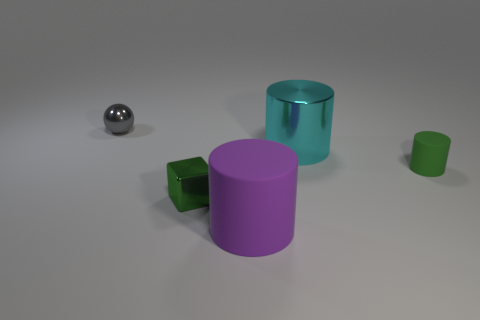Subtract all rubber cylinders. How many cylinders are left? 1 Add 1 cyan cylinders. How many objects exist? 6 Subtract all cubes. How many objects are left? 4 Subtract 0 blue cylinders. How many objects are left? 5 Subtract all green cylinders. Subtract all red cubes. How many cylinders are left? 2 Subtract all small green shiny things. Subtract all metallic cylinders. How many objects are left? 3 Add 3 big metal cylinders. How many big metal cylinders are left? 4 Add 2 small cylinders. How many small cylinders exist? 3 